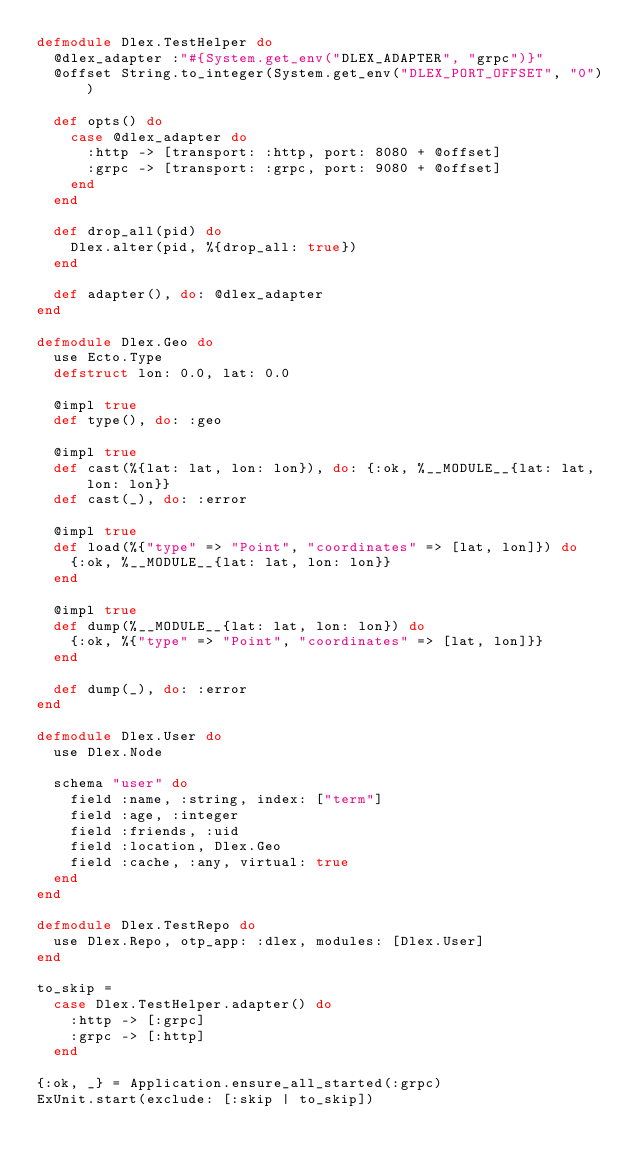Convert code to text. <code><loc_0><loc_0><loc_500><loc_500><_Elixir_>defmodule Dlex.TestHelper do
  @dlex_adapter :"#{System.get_env("DLEX_ADAPTER", "grpc")}"
  @offset String.to_integer(System.get_env("DLEX_PORT_OFFSET", "0"))

  def opts() do
    case @dlex_adapter do
      :http -> [transport: :http, port: 8080 + @offset]
      :grpc -> [transport: :grpc, port: 9080 + @offset]
    end
  end

  def drop_all(pid) do
    Dlex.alter(pid, %{drop_all: true})
  end

  def adapter(), do: @dlex_adapter
end

defmodule Dlex.Geo do
  use Ecto.Type
  defstruct lon: 0.0, lat: 0.0

  @impl true
  def type(), do: :geo

  @impl true
  def cast(%{lat: lat, lon: lon}), do: {:ok, %__MODULE__{lat: lat, lon: lon}}
  def cast(_), do: :error

  @impl true
  def load(%{"type" => "Point", "coordinates" => [lat, lon]}) do
    {:ok, %__MODULE__{lat: lat, lon: lon}}
  end

  @impl true
  def dump(%__MODULE__{lat: lat, lon: lon}) do
    {:ok, %{"type" => "Point", "coordinates" => [lat, lon]}}
  end

  def dump(_), do: :error
end

defmodule Dlex.User do
  use Dlex.Node

  schema "user" do
    field :name, :string, index: ["term"]
    field :age, :integer
    field :friends, :uid
    field :location, Dlex.Geo
    field :cache, :any, virtual: true
  end
end

defmodule Dlex.TestRepo do
  use Dlex.Repo, otp_app: :dlex, modules: [Dlex.User]
end

to_skip =
  case Dlex.TestHelper.adapter() do
    :http -> [:grpc]
    :grpc -> [:http]
  end

{:ok, _} = Application.ensure_all_started(:grpc)
ExUnit.start(exclude: [:skip | to_skip])
</code> 